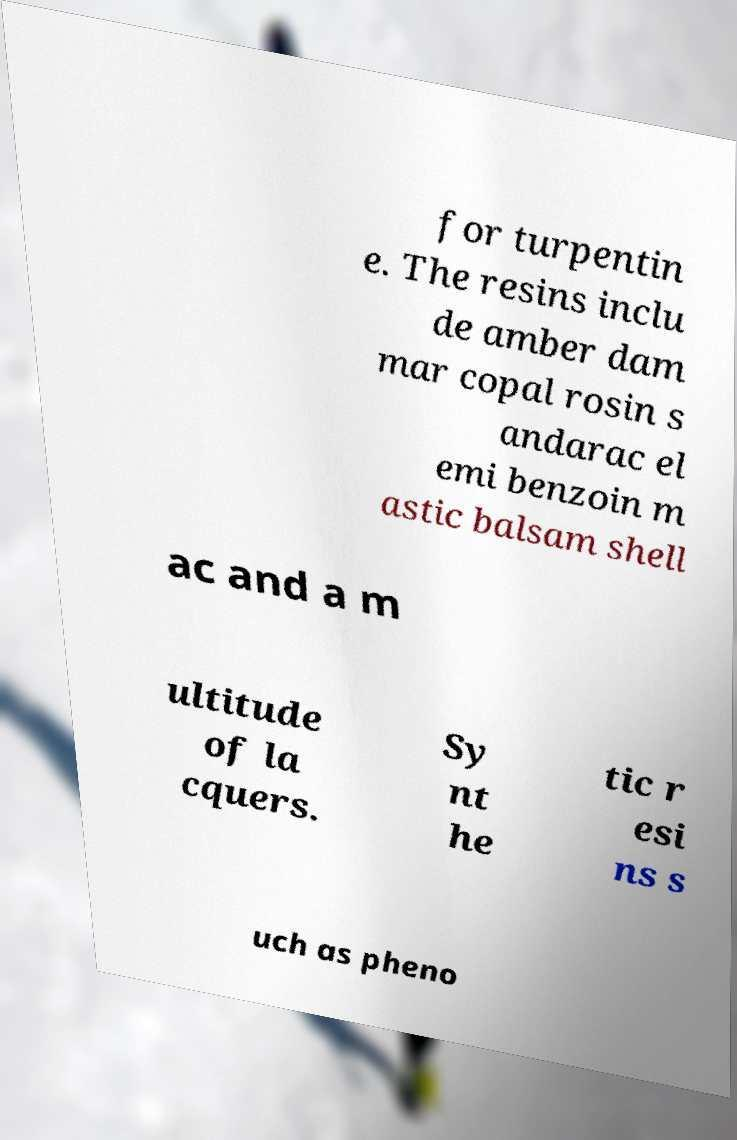Please read and relay the text visible in this image. What does it say? for turpentin e. The resins inclu de amber dam mar copal rosin s andarac el emi benzoin m astic balsam shell ac and a m ultitude of la cquers. Sy nt he tic r esi ns s uch as pheno 